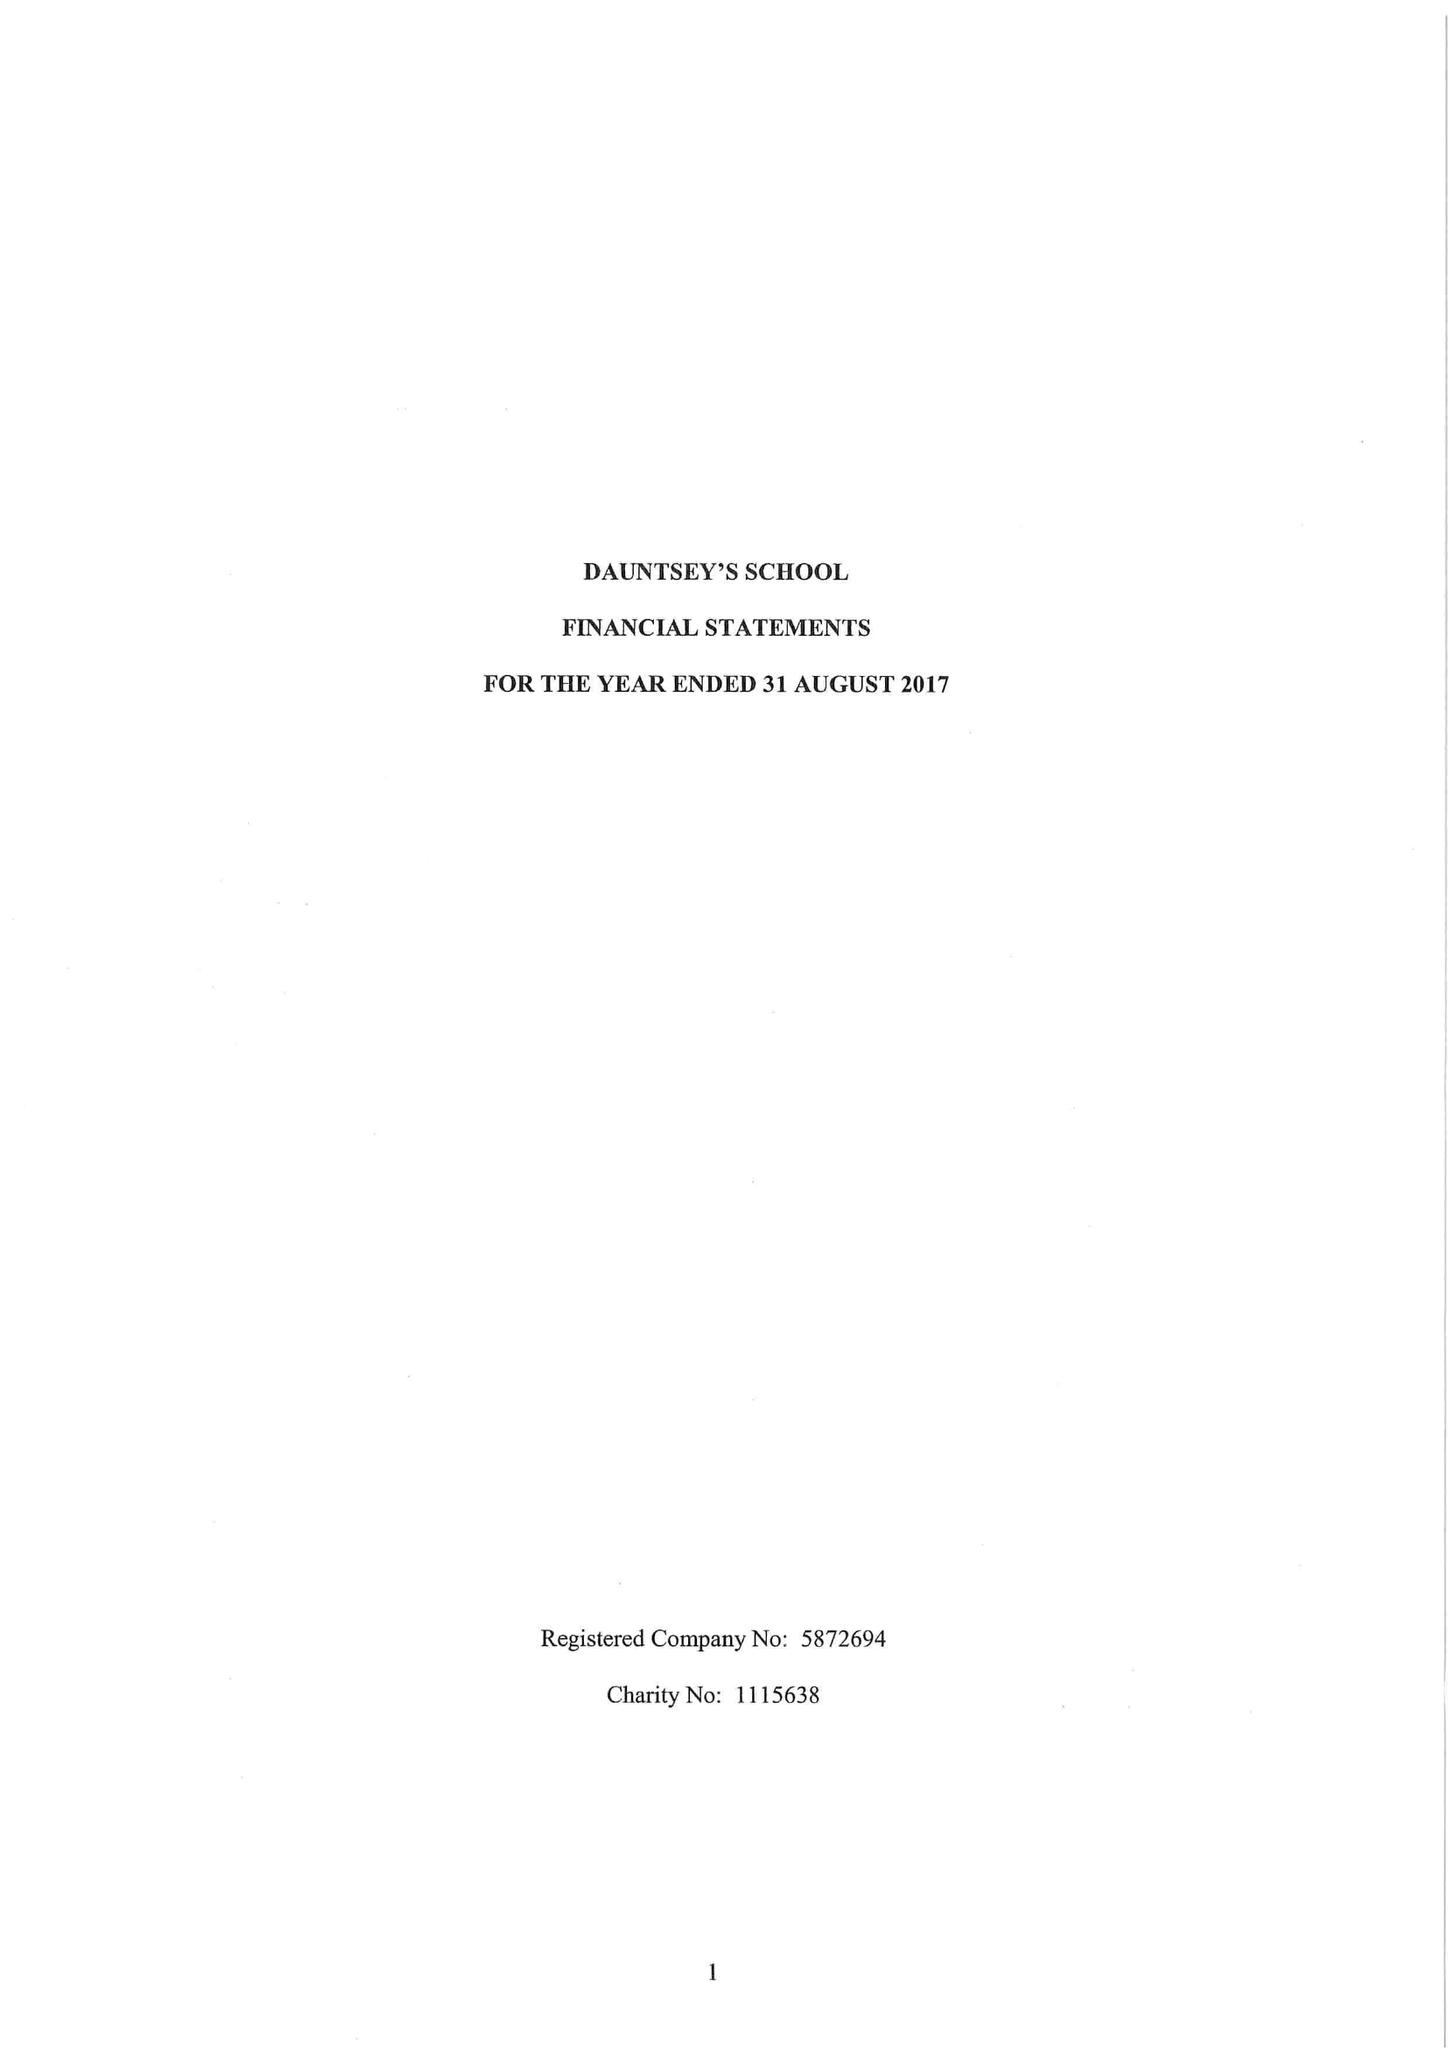What is the value for the address__street_line?
Answer the question using a single word or phrase. HIGH STREET 